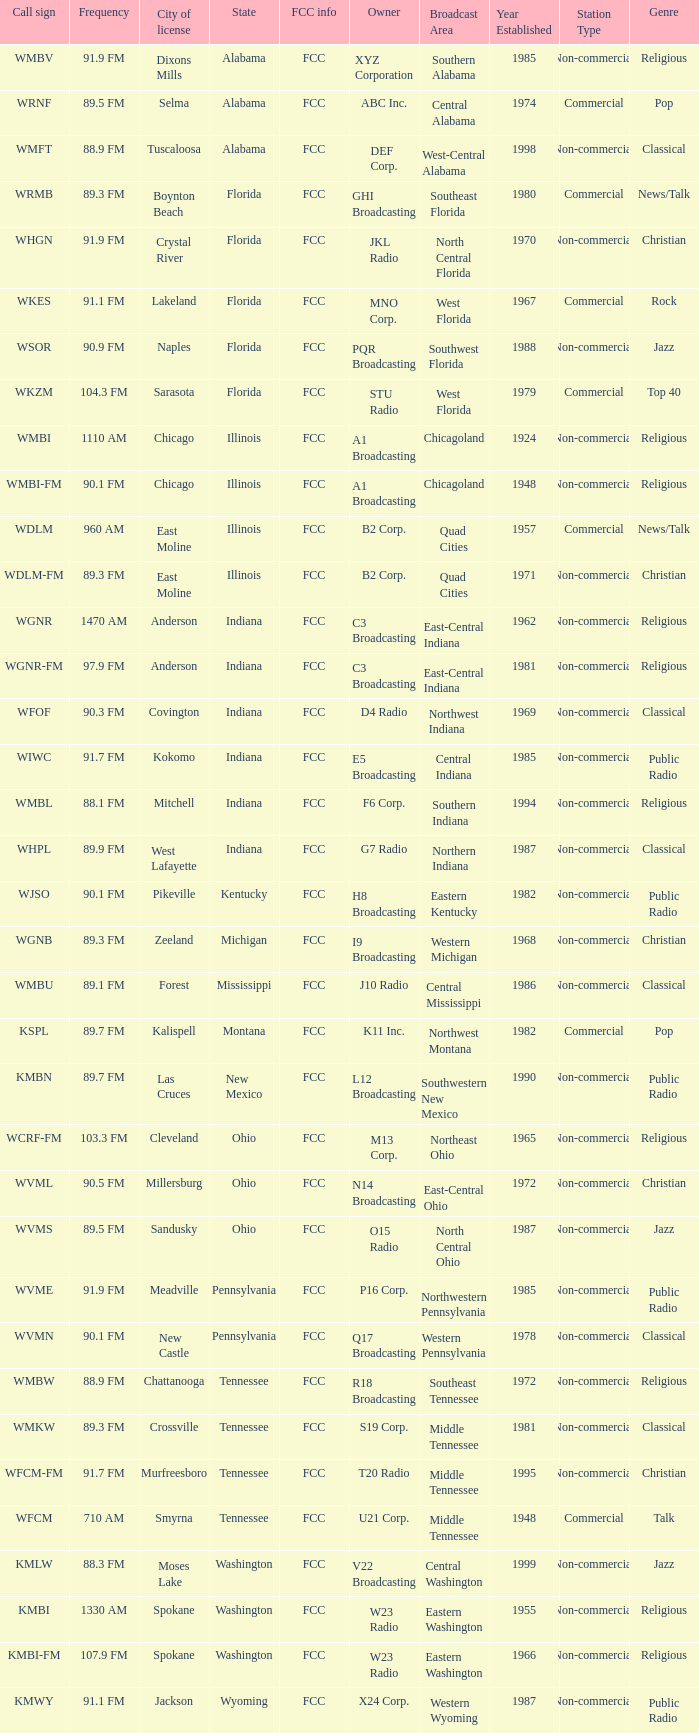What is the frequency of the radio station in Indiana that has a call sign of WGNR? 1470 AM. 